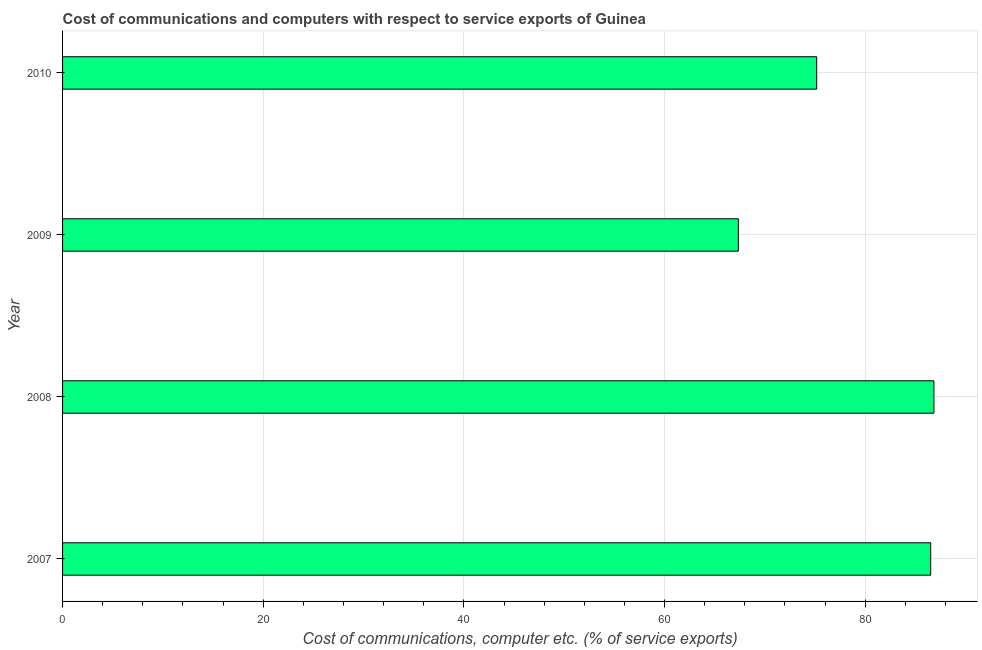Does the graph contain grids?
Offer a very short reply. Yes. What is the title of the graph?
Give a very brief answer. Cost of communications and computers with respect to service exports of Guinea. What is the label or title of the X-axis?
Offer a terse response. Cost of communications, computer etc. (% of service exports). What is the label or title of the Y-axis?
Your answer should be very brief. Year. What is the cost of communications and computer in 2007?
Provide a short and direct response. 86.53. Across all years, what is the maximum cost of communications and computer?
Your response must be concise. 86.85. Across all years, what is the minimum cost of communications and computer?
Make the answer very short. 67.36. In which year was the cost of communications and computer minimum?
Provide a succinct answer. 2009. What is the sum of the cost of communications and computer?
Your answer should be compact. 315.9. What is the difference between the cost of communications and computer in 2008 and 2010?
Offer a terse response. 11.69. What is the average cost of communications and computer per year?
Provide a succinct answer. 78.98. What is the median cost of communications and computer?
Your answer should be very brief. 80.85. Do a majority of the years between 2008 and 2010 (inclusive) have cost of communications and computer greater than 8 %?
Provide a short and direct response. Yes. What is the ratio of the cost of communications and computer in 2009 to that in 2010?
Offer a very short reply. 0.9. Is the difference between the cost of communications and computer in 2007 and 2010 greater than the difference between any two years?
Your answer should be very brief. No. What is the difference between the highest and the second highest cost of communications and computer?
Keep it short and to the point. 0.32. What is the difference between the highest and the lowest cost of communications and computer?
Make the answer very short. 19.49. In how many years, is the cost of communications and computer greater than the average cost of communications and computer taken over all years?
Ensure brevity in your answer.  2. How many years are there in the graph?
Make the answer very short. 4. What is the difference between two consecutive major ticks on the X-axis?
Give a very brief answer. 20. What is the Cost of communications, computer etc. (% of service exports) in 2007?
Make the answer very short. 86.53. What is the Cost of communications, computer etc. (% of service exports) in 2008?
Ensure brevity in your answer.  86.85. What is the Cost of communications, computer etc. (% of service exports) in 2009?
Provide a short and direct response. 67.36. What is the Cost of communications, computer etc. (% of service exports) in 2010?
Your answer should be very brief. 75.16. What is the difference between the Cost of communications, computer etc. (% of service exports) in 2007 and 2008?
Your answer should be compact. -0.32. What is the difference between the Cost of communications, computer etc. (% of service exports) in 2007 and 2009?
Your answer should be compact. 19.17. What is the difference between the Cost of communications, computer etc. (% of service exports) in 2007 and 2010?
Provide a succinct answer. 11.37. What is the difference between the Cost of communications, computer etc. (% of service exports) in 2008 and 2009?
Make the answer very short. 19.49. What is the difference between the Cost of communications, computer etc. (% of service exports) in 2008 and 2010?
Give a very brief answer. 11.69. What is the difference between the Cost of communications, computer etc. (% of service exports) in 2009 and 2010?
Your answer should be compact. -7.81. What is the ratio of the Cost of communications, computer etc. (% of service exports) in 2007 to that in 2009?
Make the answer very short. 1.28. What is the ratio of the Cost of communications, computer etc. (% of service exports) in 2007 to that in 2010?
Keep it short and to the point. 1.15. What is the ratio of the Cost of communications, computer etc. (% of service exports) in 2008 to that in 2009?
Provide a succinct answer. 1.29. What is the ratio of the Cost of communications, computer etc. (% of service exports) in 2008 to that in 2010?
Your answer should be compact. 1.16. What is the ratio of the Cost of communications, computer etc. (% of service exports) in 2009 to that in 2010?
Ensure brevity in your answer.  0.9. 